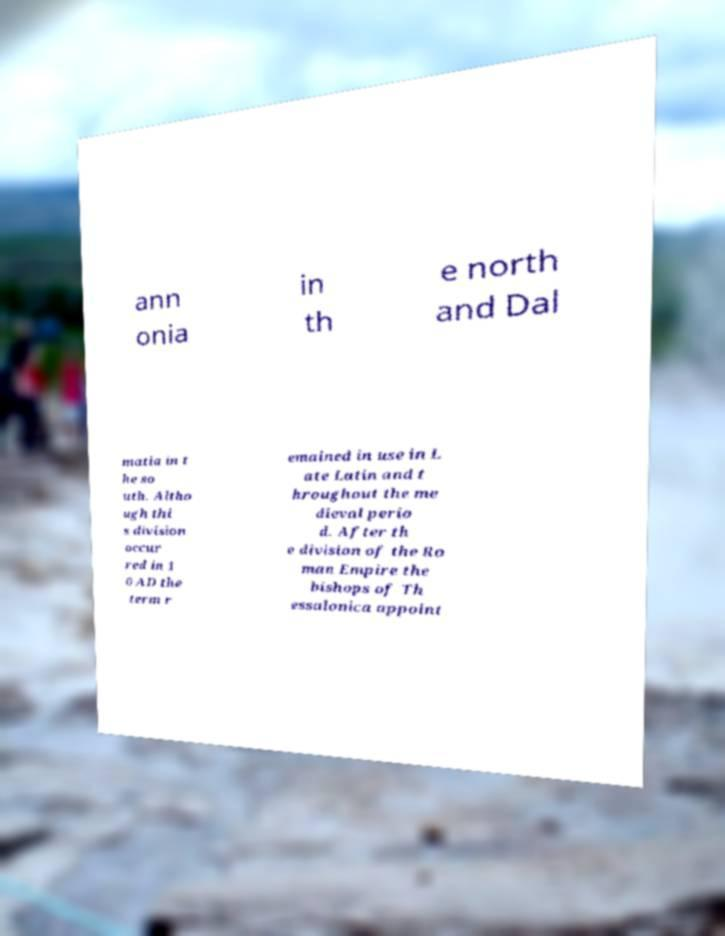Please read and relay the text visible in this image. What does it say? ann onia in th e north and Dal matia in t he so uth. Altho ugh thi s division occur red in 1 0 AD the term r emained in use in L ate Latin and t hroughout the me dieval perio d. After th e division of the Ro man Empire the bishops of Th essalonica appoint 